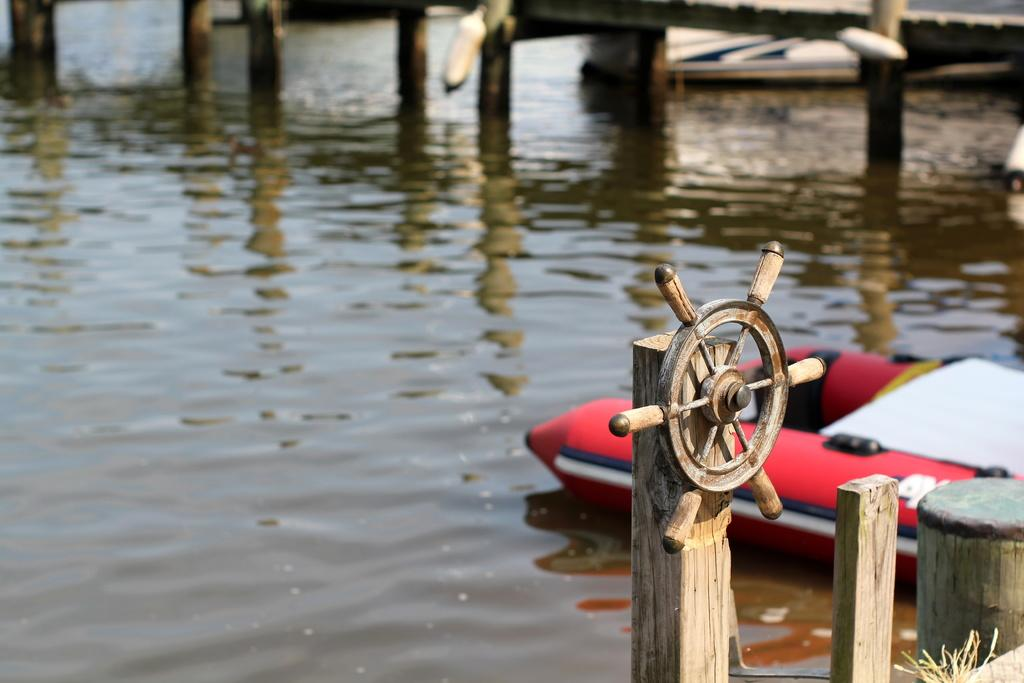What is the primary element in the image? The image consists of water. What structures can be seen in the front of the image? There are pillars of a bridge in the front of the image. What type of vehicle is present in the image? There is a boat on the right side of the image. Can you describe an object with a wheel in the image? There is a wheel fixed to a wooden piece in the image. What type of pie is being served on the boat in the image? There is no pie present in the image; it features a boat on the water with a wheel fixed to a wooden piece. 